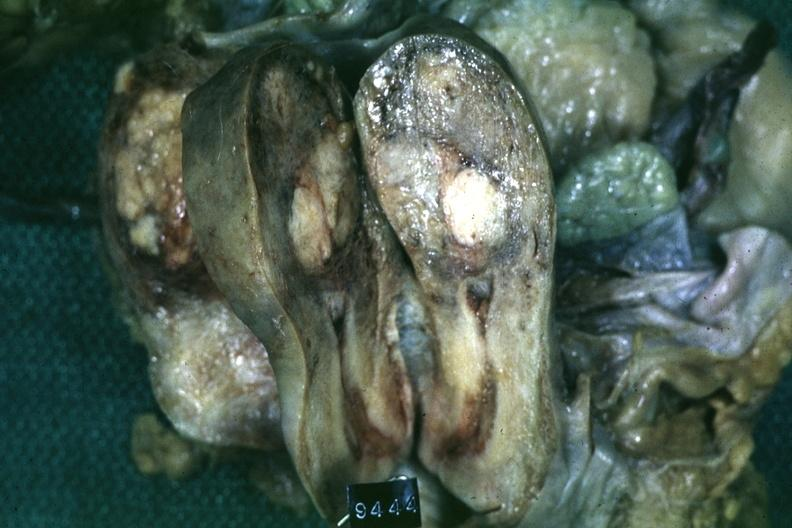does this image show fixed tissue saggital section of organ with cross sectioned myoma?
Answer the question using a single word or phrase. Yes 